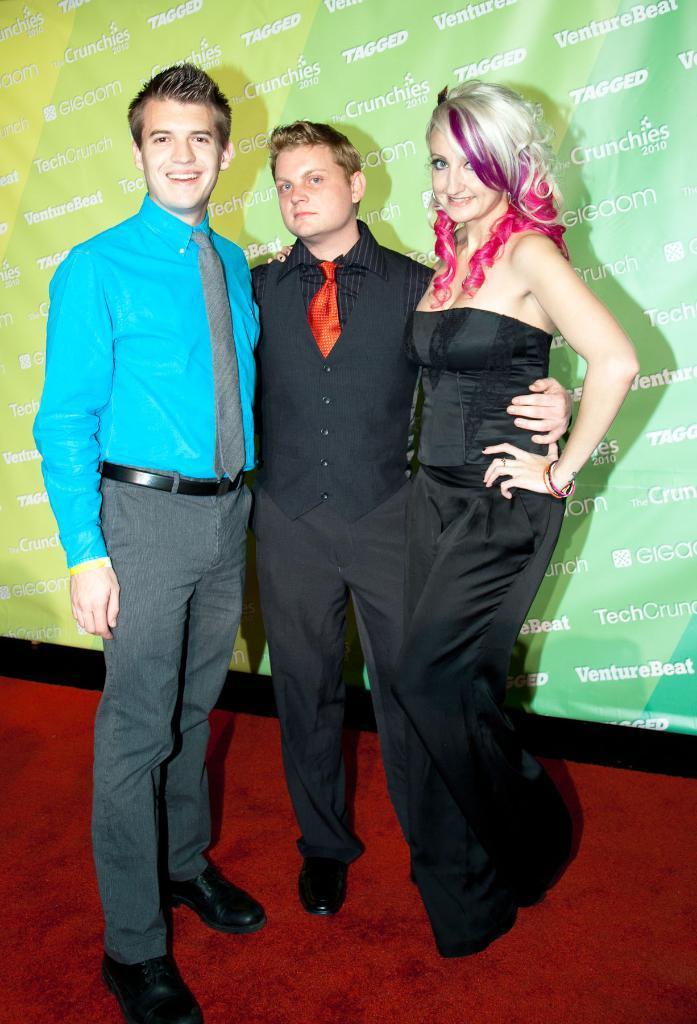How would you summarize this image in a sentence or two? In the picture there are two men and one woman standing on a red carpet, behind them there is a board with the text. 